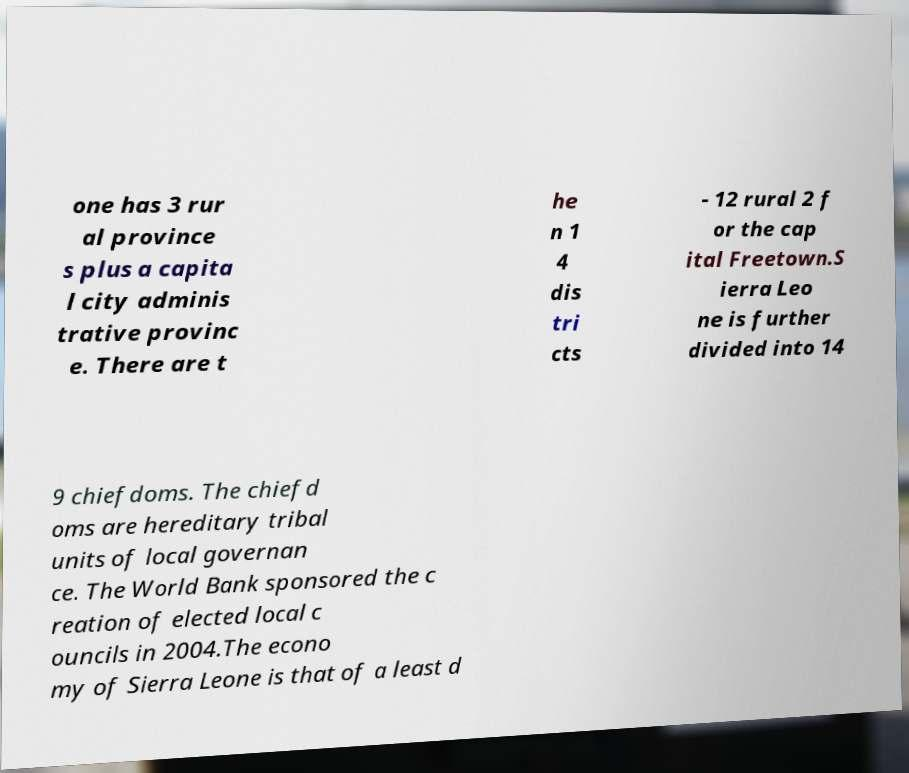There's text embedded in this image that I need extracted. Can you transcribe it verbatim? one has 3 rur al province s plus a capita l city adminis trative provinc e. There are t he n 1 4 dis tri cts - 12 rural 2 f or the cap ital Freetown.S ierra Leo ne is further divided into 14 9 chiefdoms. The chiefd oms are hereditary tribal units of local governan ce. The World Bank sponsored the c reation of elected local c ouncils in 2004.The econo my of Sierra Leone is that of a least d 